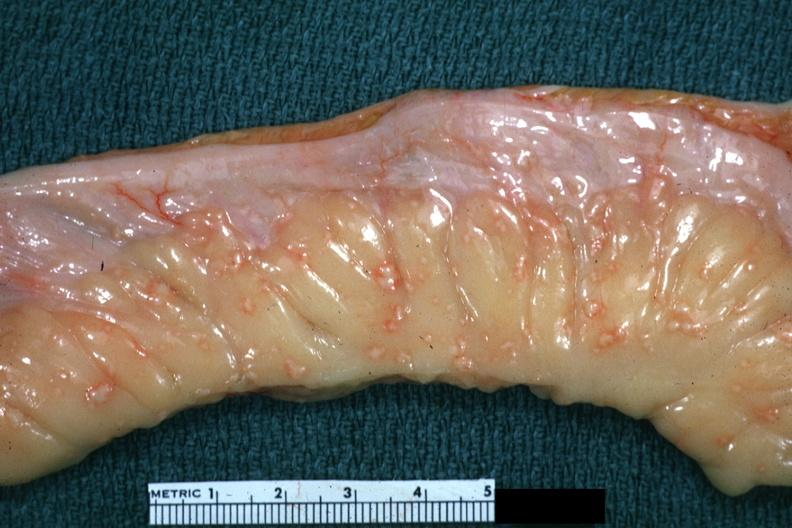what does this image show?
Answer the question using a single word or phrase. Rather close-up excellent depiction of lesions of tuberculous peritonitis 